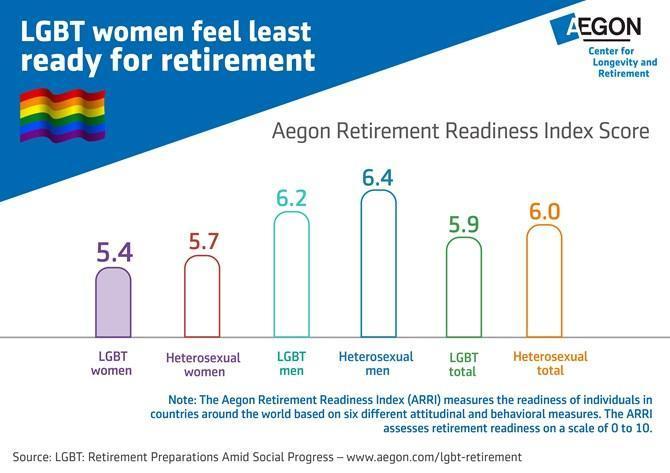Who has the least Aegon retirement readiness index score among Heterosexuals?
Answer the question with a short phrase. Heterosexual women Who is most ready for retirement? Heterosexual men 